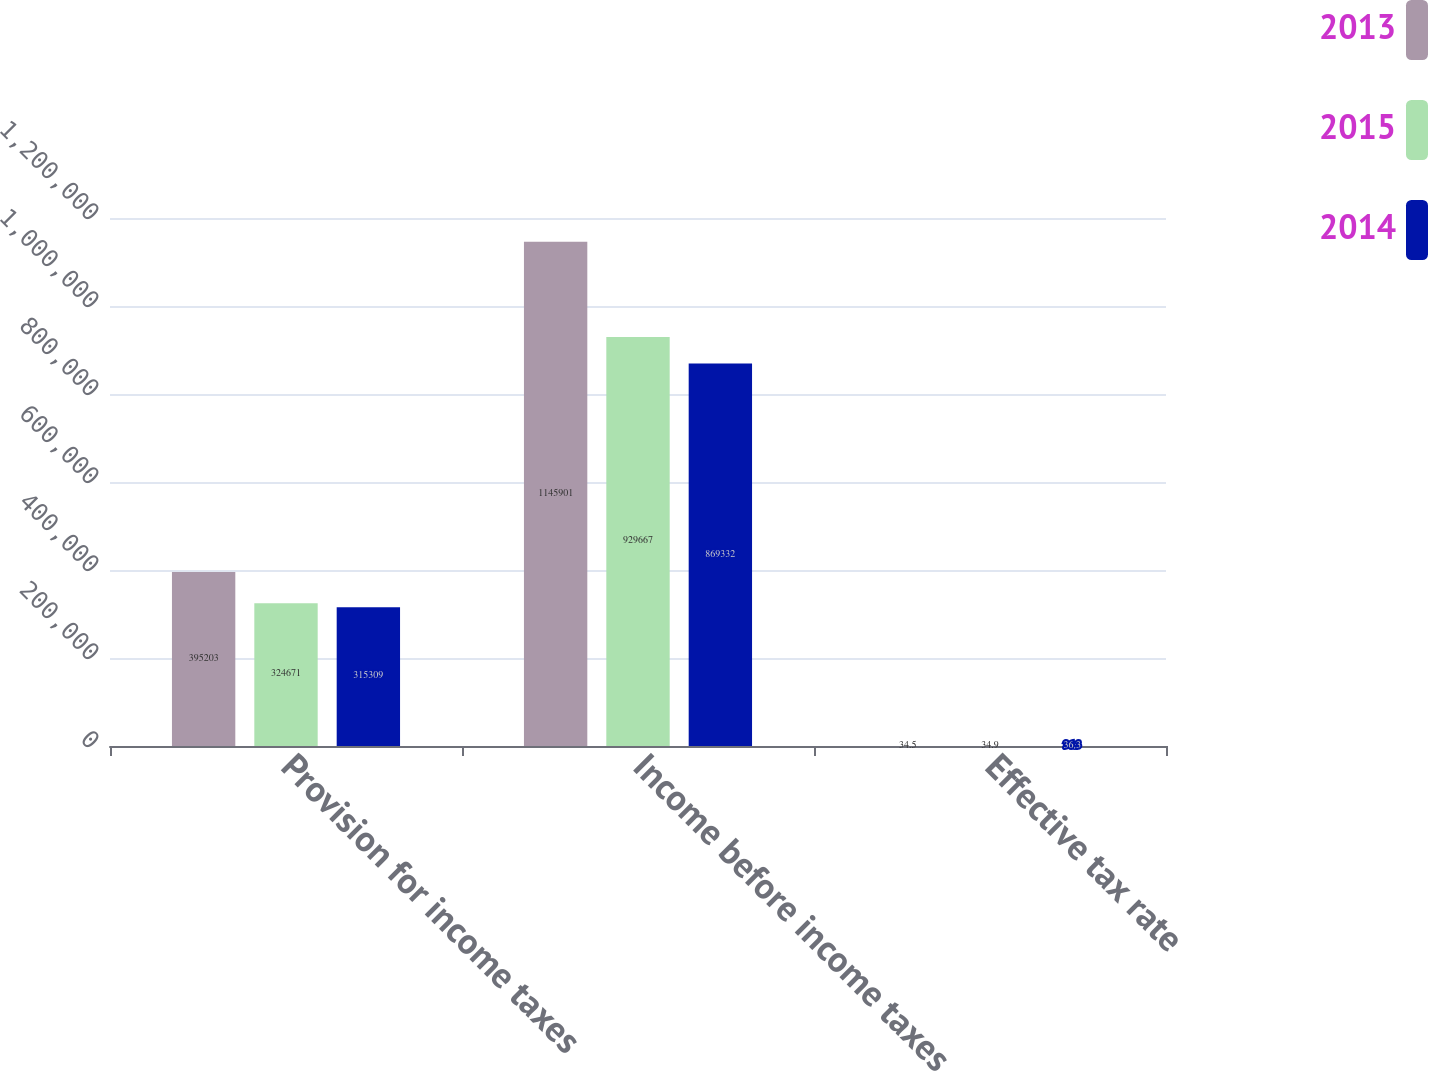Convert chart. <chart><loc_0><loc_0><loc_500><loc_500><stacked_bar_chart><ecel><fcel>Provision for income taxes<fcel>Income before income taxes<fcel>Effective tax rate<nl><fcel>2013<fcel>395203<fcel>1.1459e+06<fcel>34.5<nl><fcel>2015<fcel>324671<fcel>929667<fcel>34.9<nl><fcel>2014<fcel>315309<fcel>869332<fcel>36.3<nl></chart> 